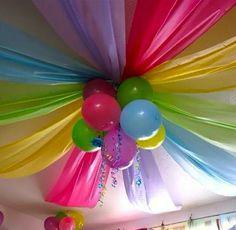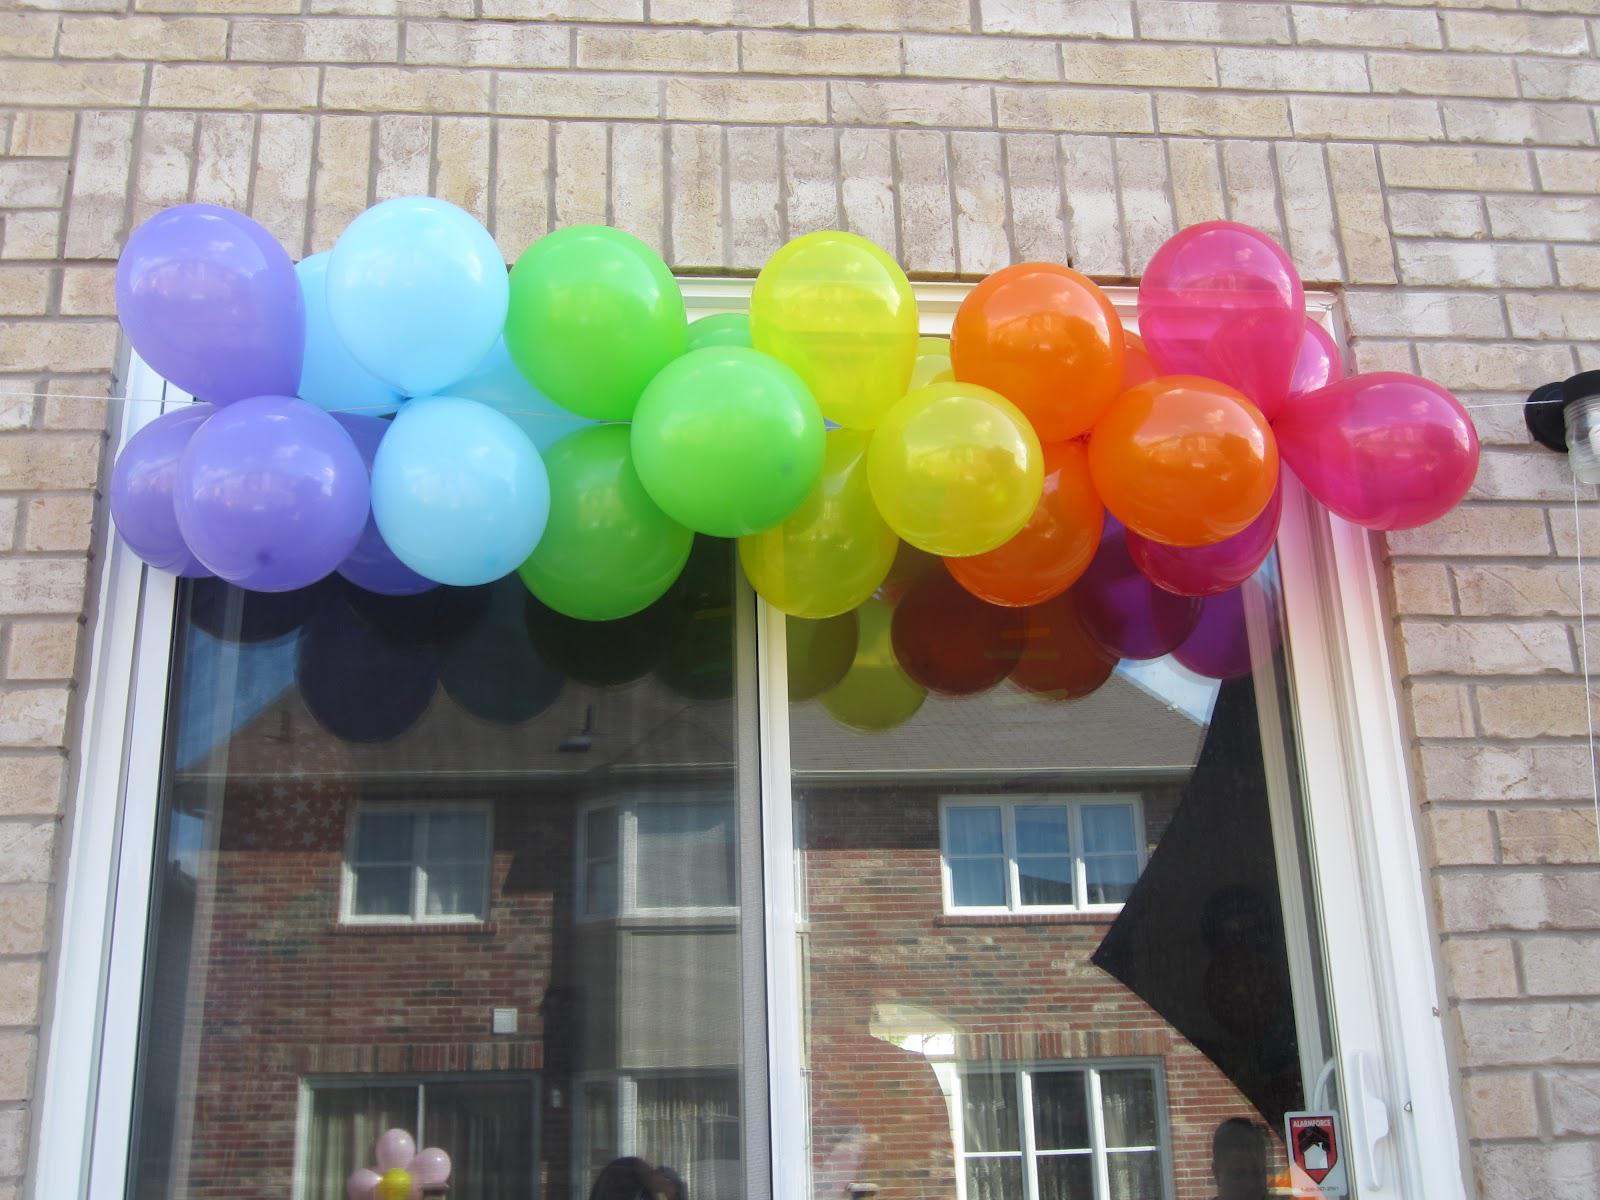The first image is the image on the left, the second image is the image on the right. Assess this claim about the two images: "One of the images shows someone holding at least one balloon and the other image shows a bunch of balloons in different colors.". Correct or not? Answer yes or no. No. The first image is the image on the left, the second image is the image on the right. Examine the images to the left and right. Is the description "In one image there is a person holding at least 1 balloon." accurate? Answer yes or no. No. 